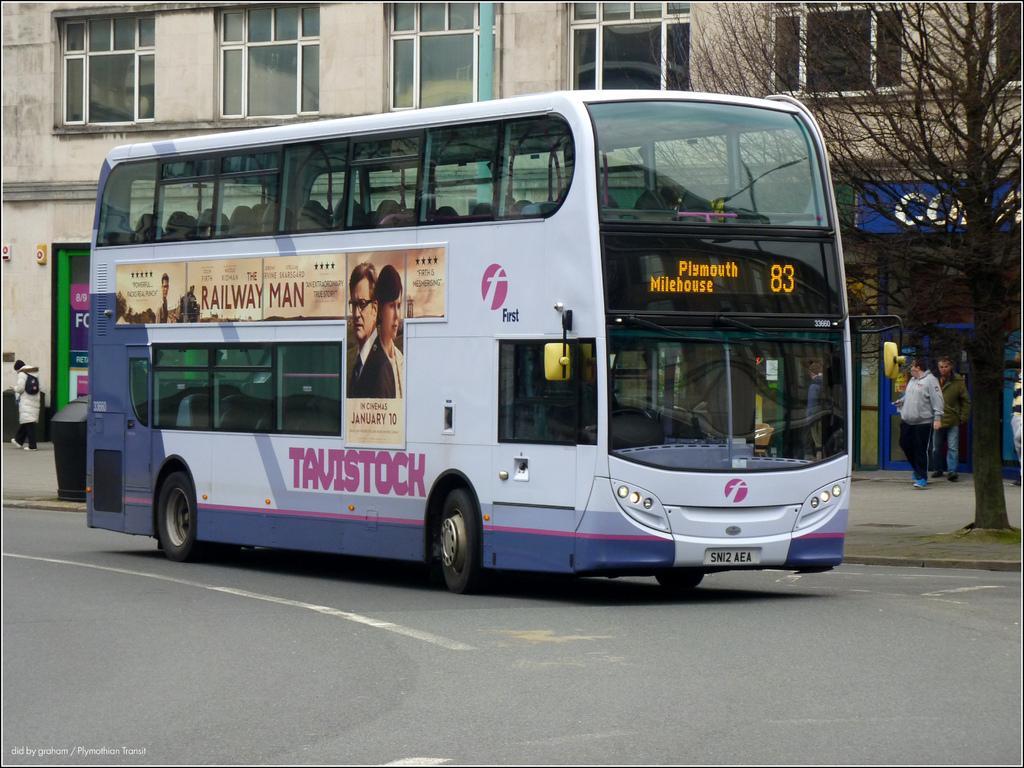Please provide a concise description of this image. In the center of the image we can see one bus on the road. And we can see one poster on the bus. On the poster, we can see two persons and some text. In the background there is a building, windows, one tree, banners, one dustbin, few people are standing and a few other objects. 